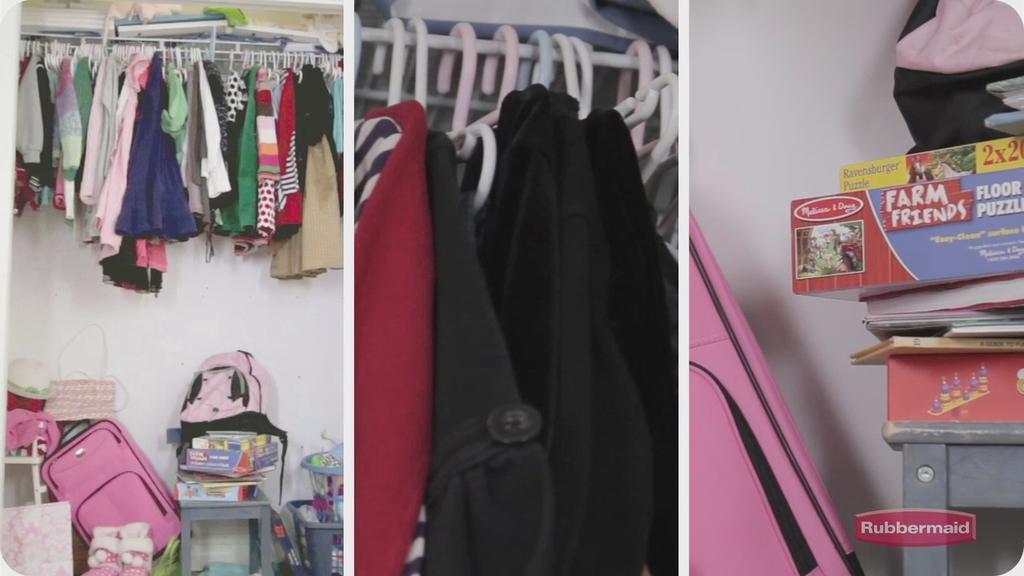What is the theme of the floor puzzle?
Keep it short and to the point. Farm friends. 